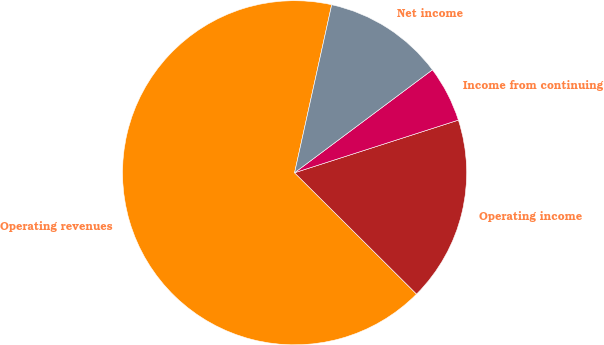Convert chart to OTSL. <chart><loc_0><loc_0><loc_500><loc_500><pie_chart><fcel>Operating revenues<fcel>Operating income<fcel>Income from continuing<fcel>Net income<nl><fcel>66.01%<fcel>17.41%<fcel>5.26%<fcel>11.33%<nl></chart> 